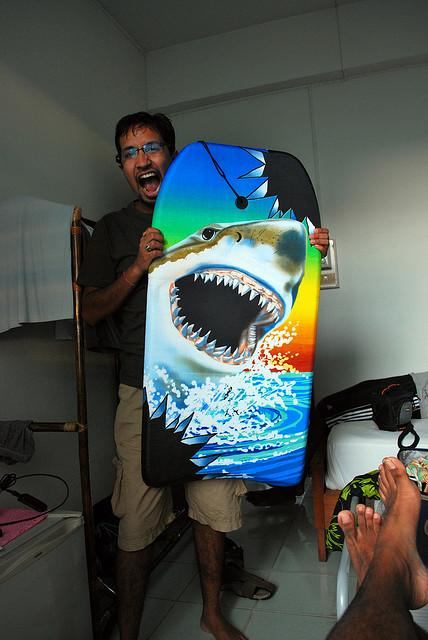What is the item being displayed by the man?

Choices:
A) floaty
B) surf board
C) drawing
D) wall paper floaty 